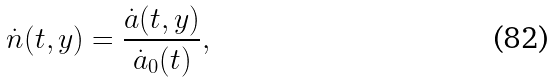<formula> <loc_0><loc_0><loc_500><loc_500>\dot { n } ( t , y ) = \frac { \dot { a } ( t , y ) } { \dot { a } _ { 0 } ( t ) } ,</formula> 